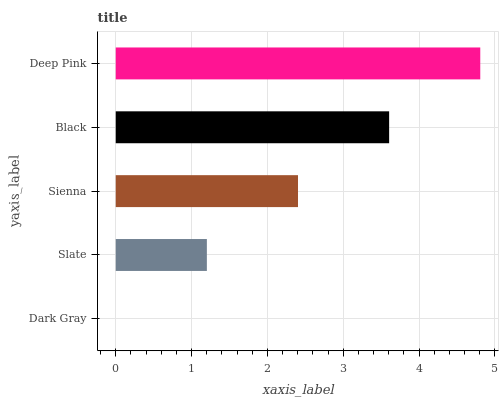Is Dark Gray the minimum?
Answer yes or no. Yes. Is Deep Pink the maximum?
Answer yes or no. Yes. Is Slate the minimum?
Answer yes or no. No. Is Slate the maximum?
Answer yes or no. No. Is Slate greater than Dark Gray?
Answer yes or no. Yes. Is Dark Gray less than Slate?
Answer yes or no. Yes. Is Dark Gray greater than Slate?
Answer yes or no. No. Is Slate less than Dark Gray?
Answer yes or no. No. Is Sienna the high median?
Answer yes or no. Yes. Is Sienna the low median?
Answer yes or no. Yes. Is Deep Pink the high median?
Answer yes or no. No. Is Dark Gray the low median?
Answer yes or no. No. 